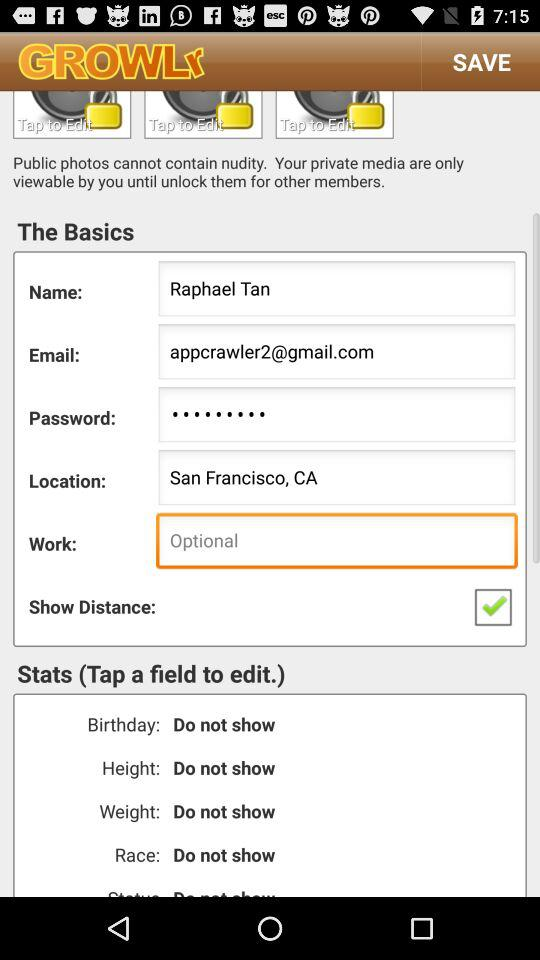Which option is checked? The checked option is "Show Distance:". 